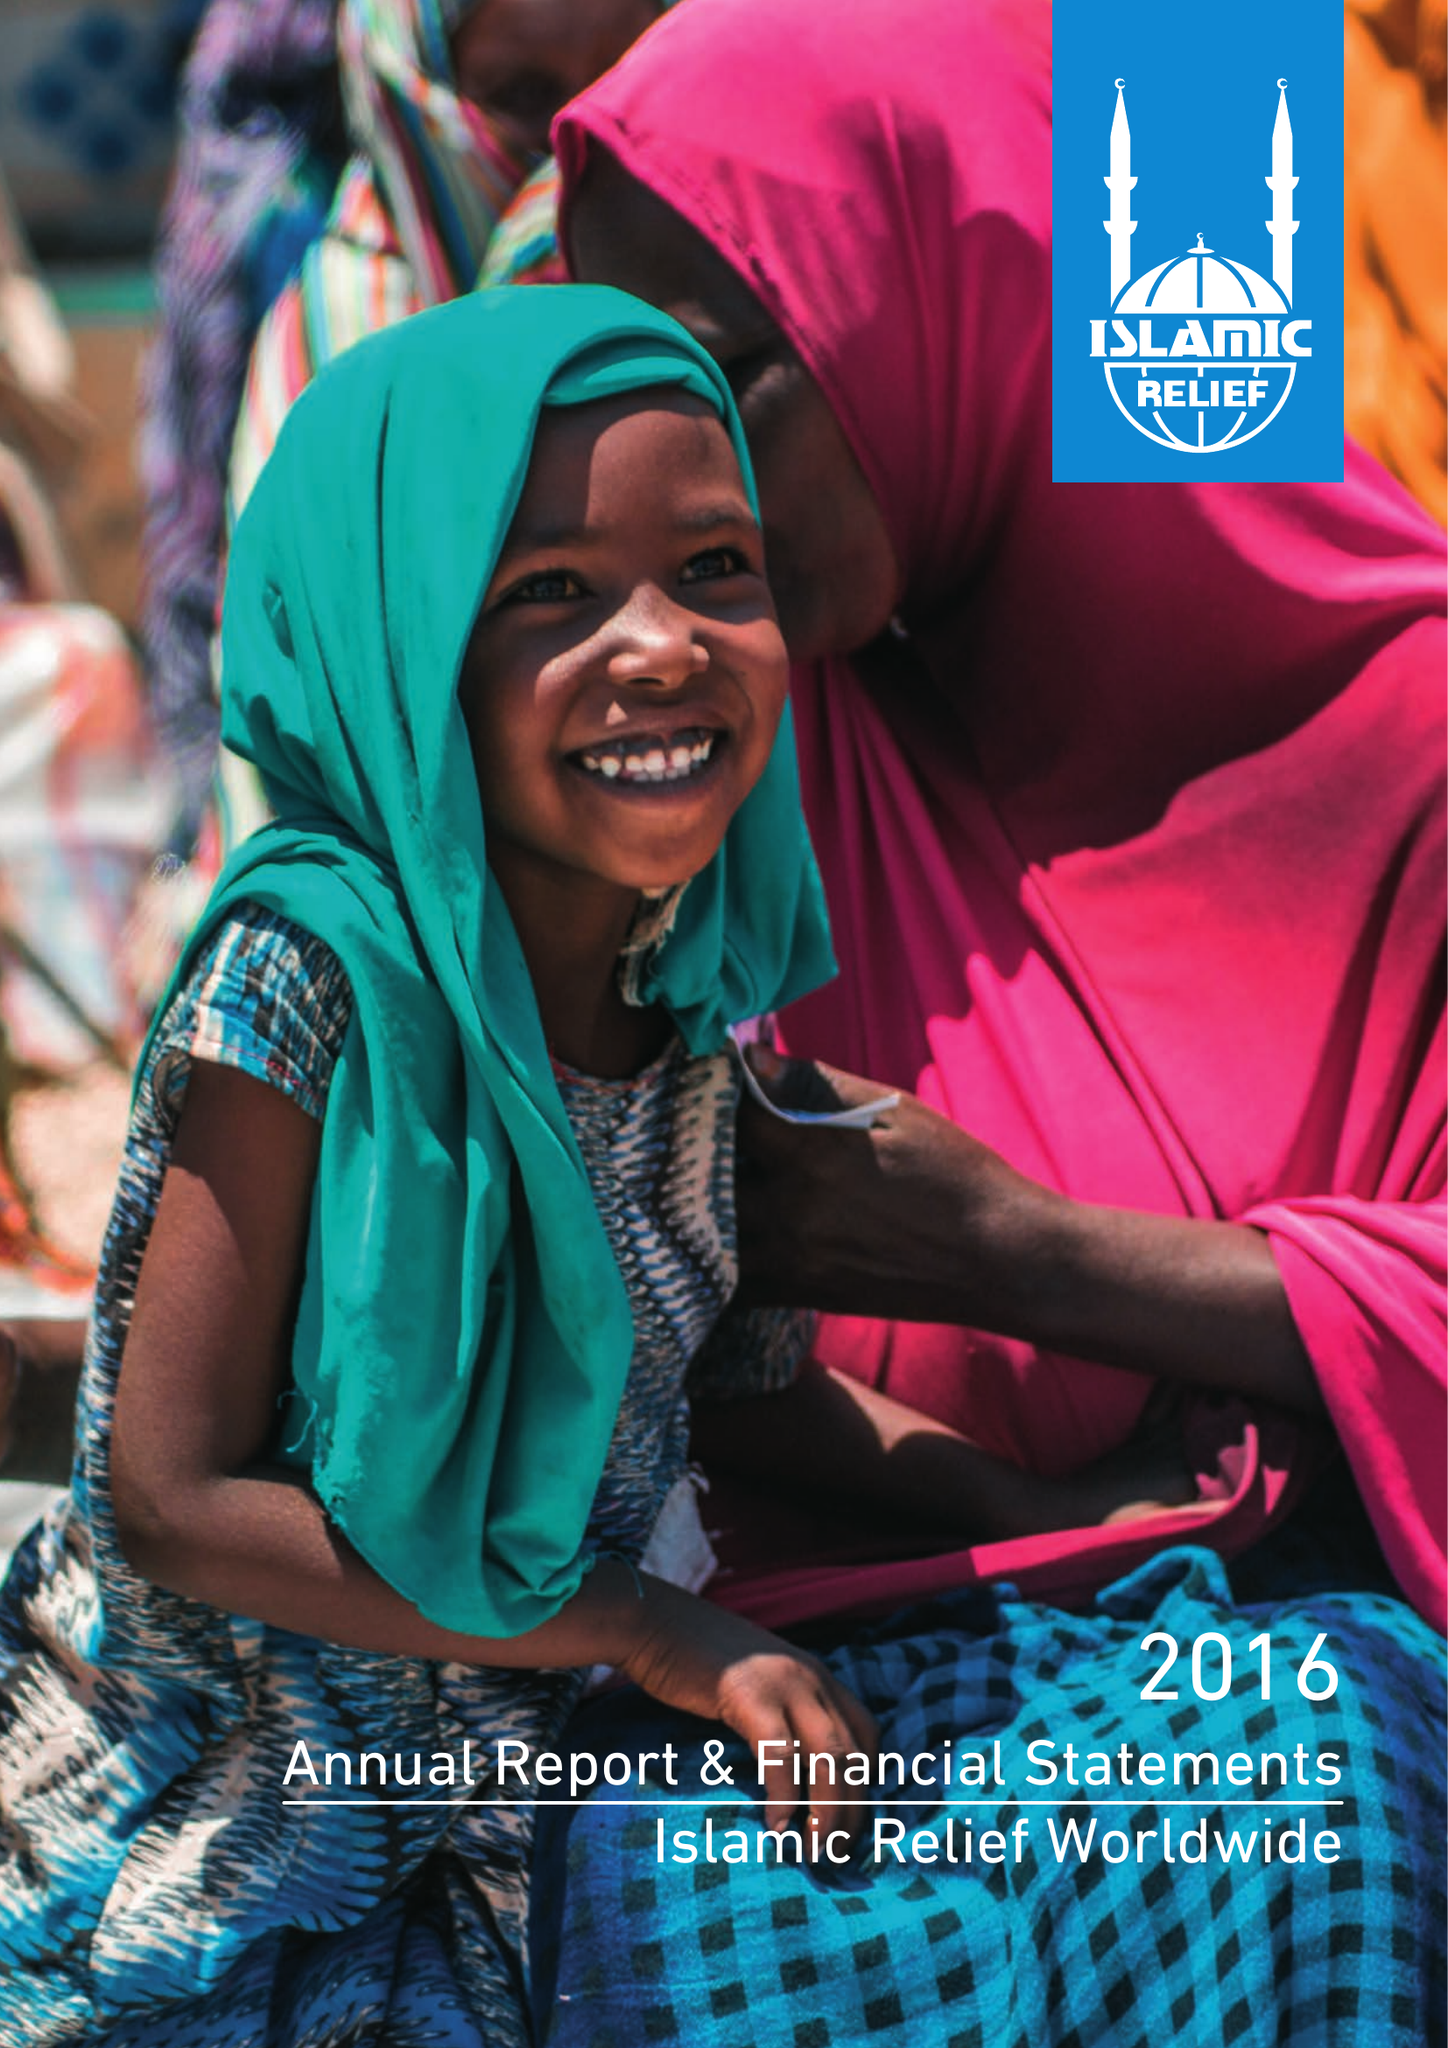What is the value for the charity_name?
Answer the question using a single word or phrase. Islamic Relief Worldwide 